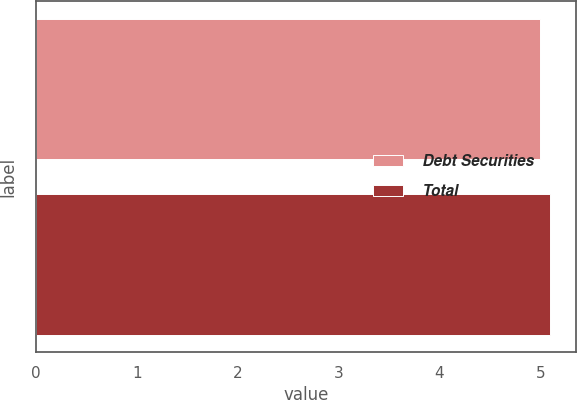Convert chart to OTSL. <chart><loc_0><loc_0><loc_500><loc_500><bar_chart><fcel>Debt Securities<fcel>Total<nl><fcel>5<fcel>5.1<nl></chart> 